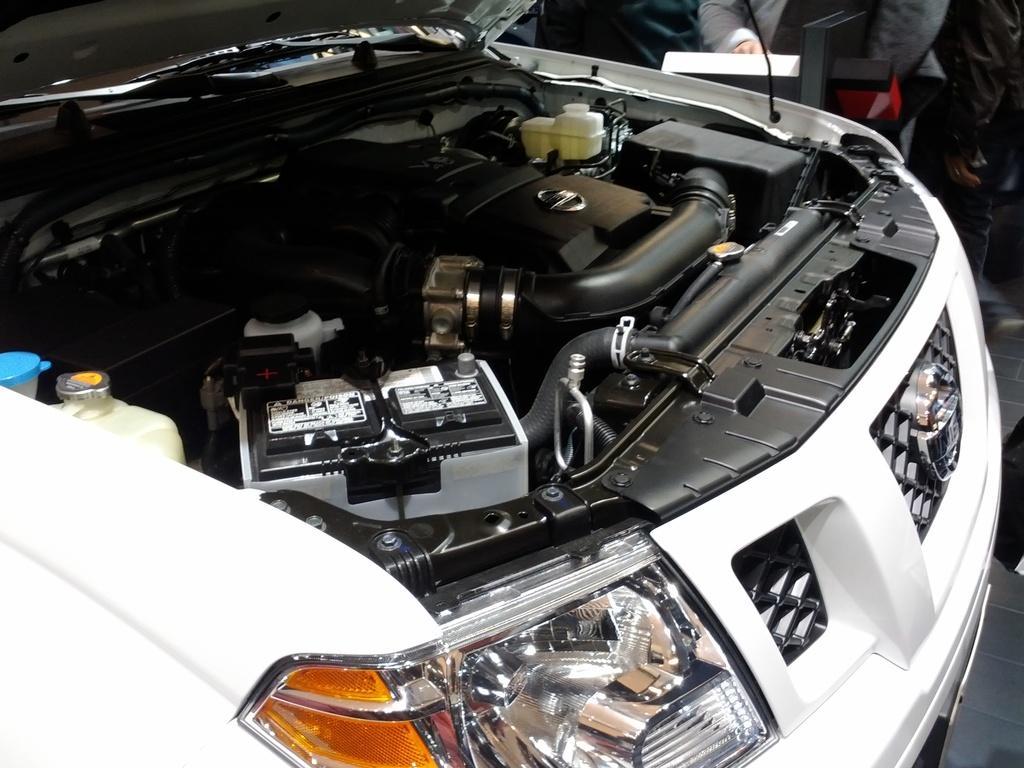Can you describe this image briefly? In this picture I can observe an engine of a car. This engine is in black color and the car is in white color. 